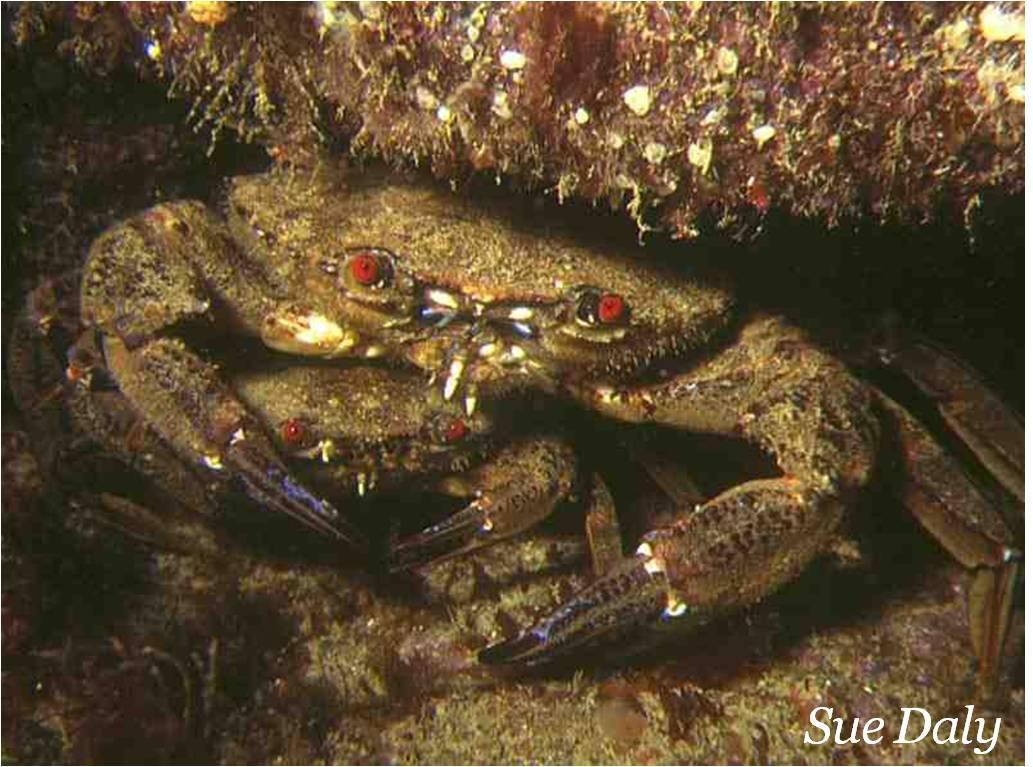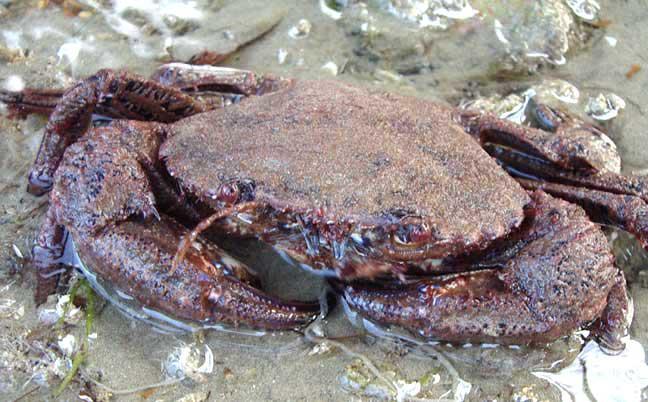The first image is the image on the left, the second image is the image on the right. Assess this claim about the two images: "Three pairs of eyes are visible.". Correct or not? Answer yes or no. Yes. 